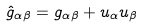<formula> <loc_0><loc_0><loc_500><loc_500>\hat { g } _ { \alpha \beta } = g _ { \alpha \beta } + u _ { \alpha } u _ { \beta }</formula> 